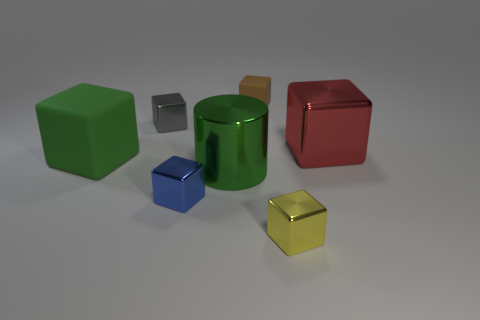Subtract all brown blocks. How many blocks are left? 5 Subtract all tiny rubber blocks. How many blocks are left? 5 Subtract all yellow cubes. Subtract all blue spheres. How many cubes are left? 5 Add 2 large yellow cubes. How many objects exist? 9 Subtract all blocks. How many objects are left? 1 Add 6 large blue matte blocks. How many large blue matte blocks exist? 6 Subtract 0 red cylinders. How many objects are left? 7 Subtract all brown rubber cubes. Subtract all small yellow shiny blocks. How many objects are left? 5 Add 4 small blue shiny objects. How many small blue shiny objects are left? 5 